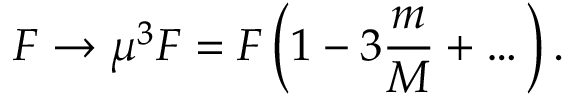Convert formula to latex. <formula><loc_0><loc_0><loc_500><loc_500>F \rightarrow \mu ^ { 3 } F = F \left ( 1 - 3 \frac { m } { M } + \dots \right ) .</formula> 